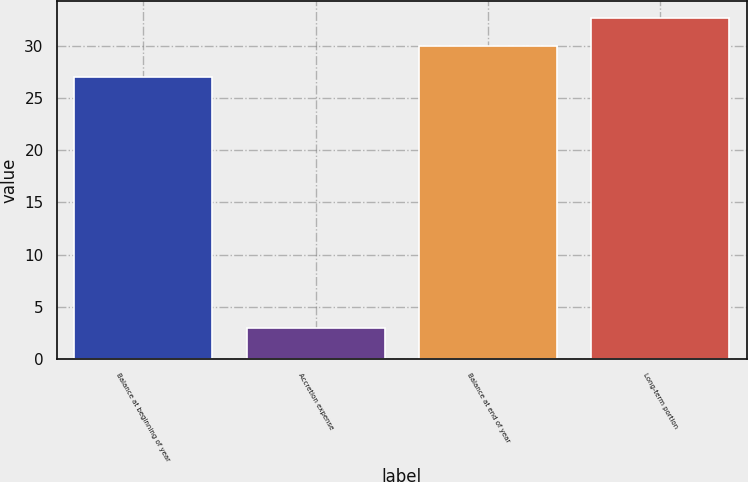Convert chart to OTSL. <chart><loc_0><loc_0><loc_500><loc_500><bar_chart><fcel>Balance at beginning of year<fcel>Accretion expense<fcel>Balance at end of year<fcel>Long-term portion<nl><fcel>27<fcel>3<fcel>30<fcel>32.7<nl></chart> 